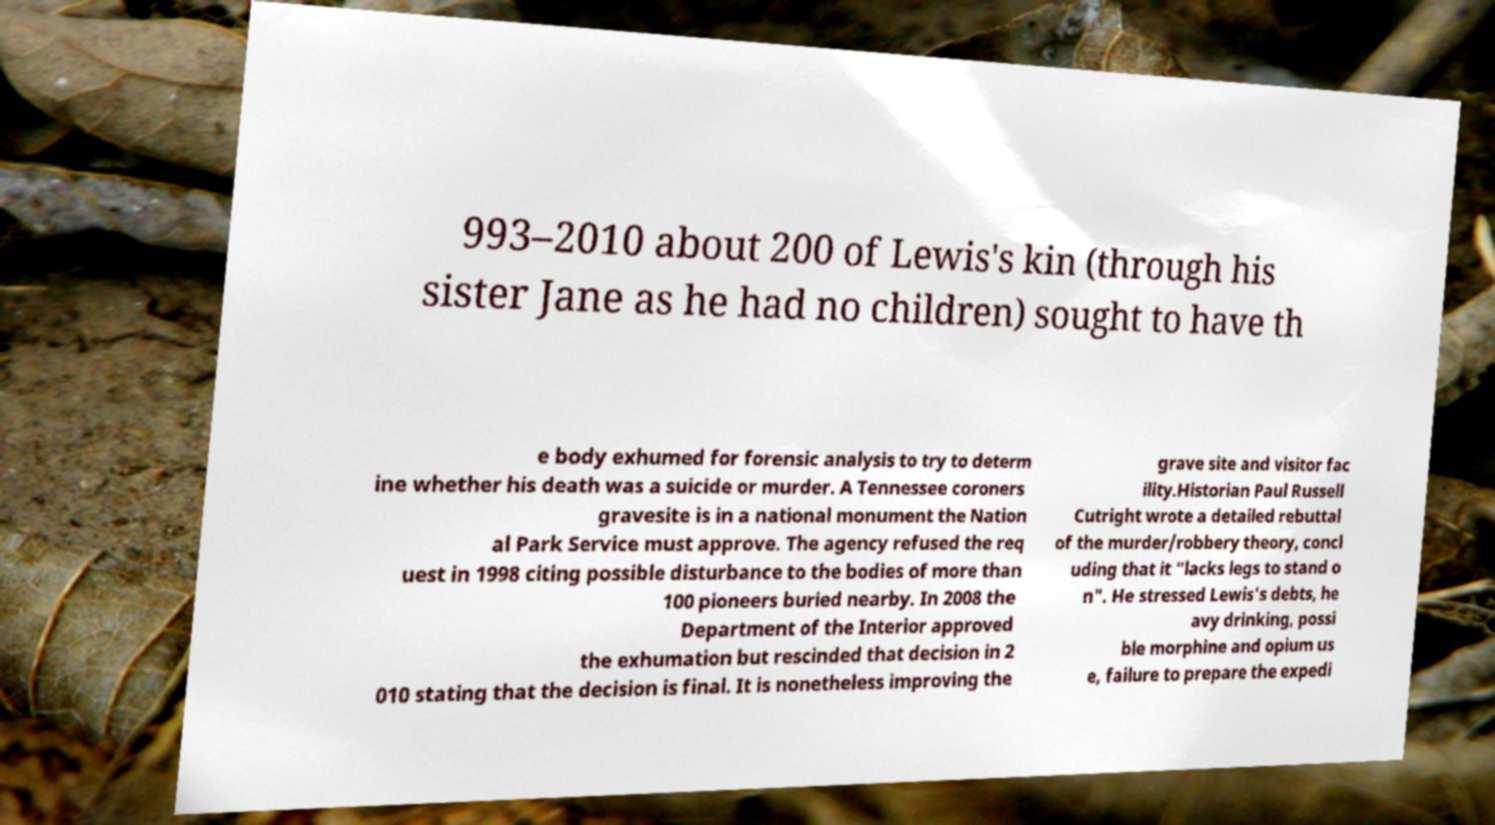What messages or text are displayed in this image? I need them in a readable, typed format. 993–2010 about 200 of Lewis's kin (through his sister Jane as he had no children) sought to have th e body exhumed for forensic analysis to try to determ ine whether his death was a suicide or murder. A Tennessee coroners gravesite is in a national monument the Nation al Park Service must approve. The agency refused the req uest in 1998 citing possible disturbance to the bodies of more than 100 pioneers buried nearby. In 2008 the Department of the Interior approved the exhumation but rescinded that decision in 2 010 stating that the decision is final. It is nonetheless improving the grave site and visitor fac ility.Historian Paul Russell Cutright wrote a detailed rebuttal of the murder/robbery theory, concl uding that it "lacks legs to stand o n". He stressed Lewis's debts, he avy drinking, possi ble morphine and opium us e, failure to prepare the expedi 